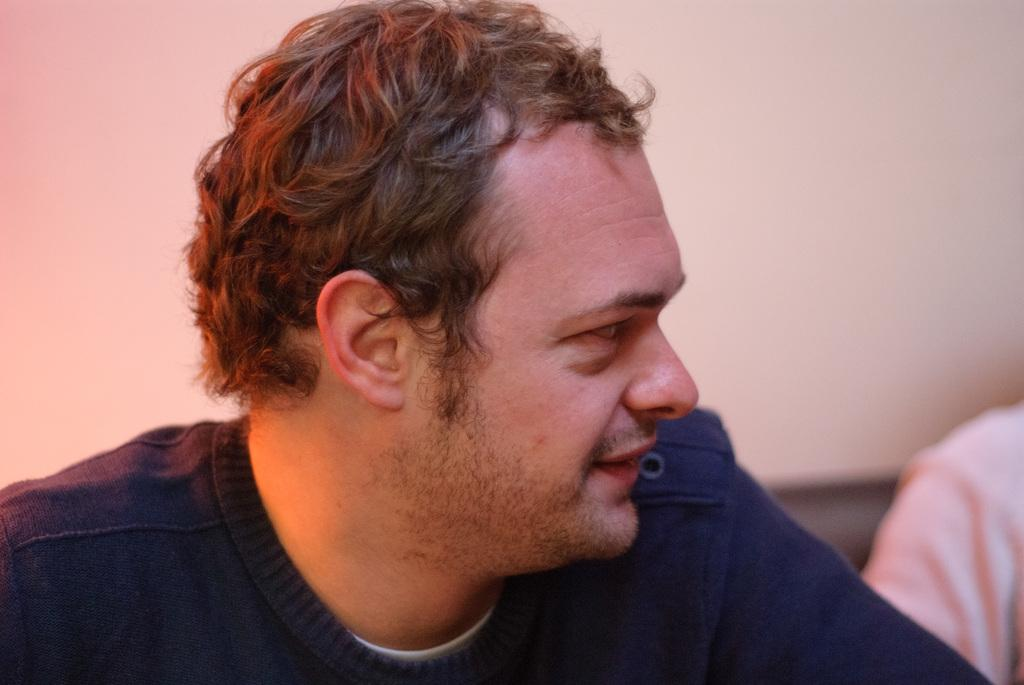What is the gender of the person in the image? There is a man in the image. What is the man wearing? The man is wearing a blue dress. What is the man's facial expression? The man is smiling. In which direction is the man looking? The man is looking to the right side. Whose hand is visible on the right side of the image? There is another person's hand visible on the right side. What can be seen in the background of the image? There is a wall in the background of the image. What type of maid is cleaning the floor in the image? There is no maid or cleaning activity present in the image. What shape is the square that the man is standing on in the image? There is no square visible in the image. What arithmetic problem is the man solving in the image? There is no arithmetic problem or indication of solving one in the image. 